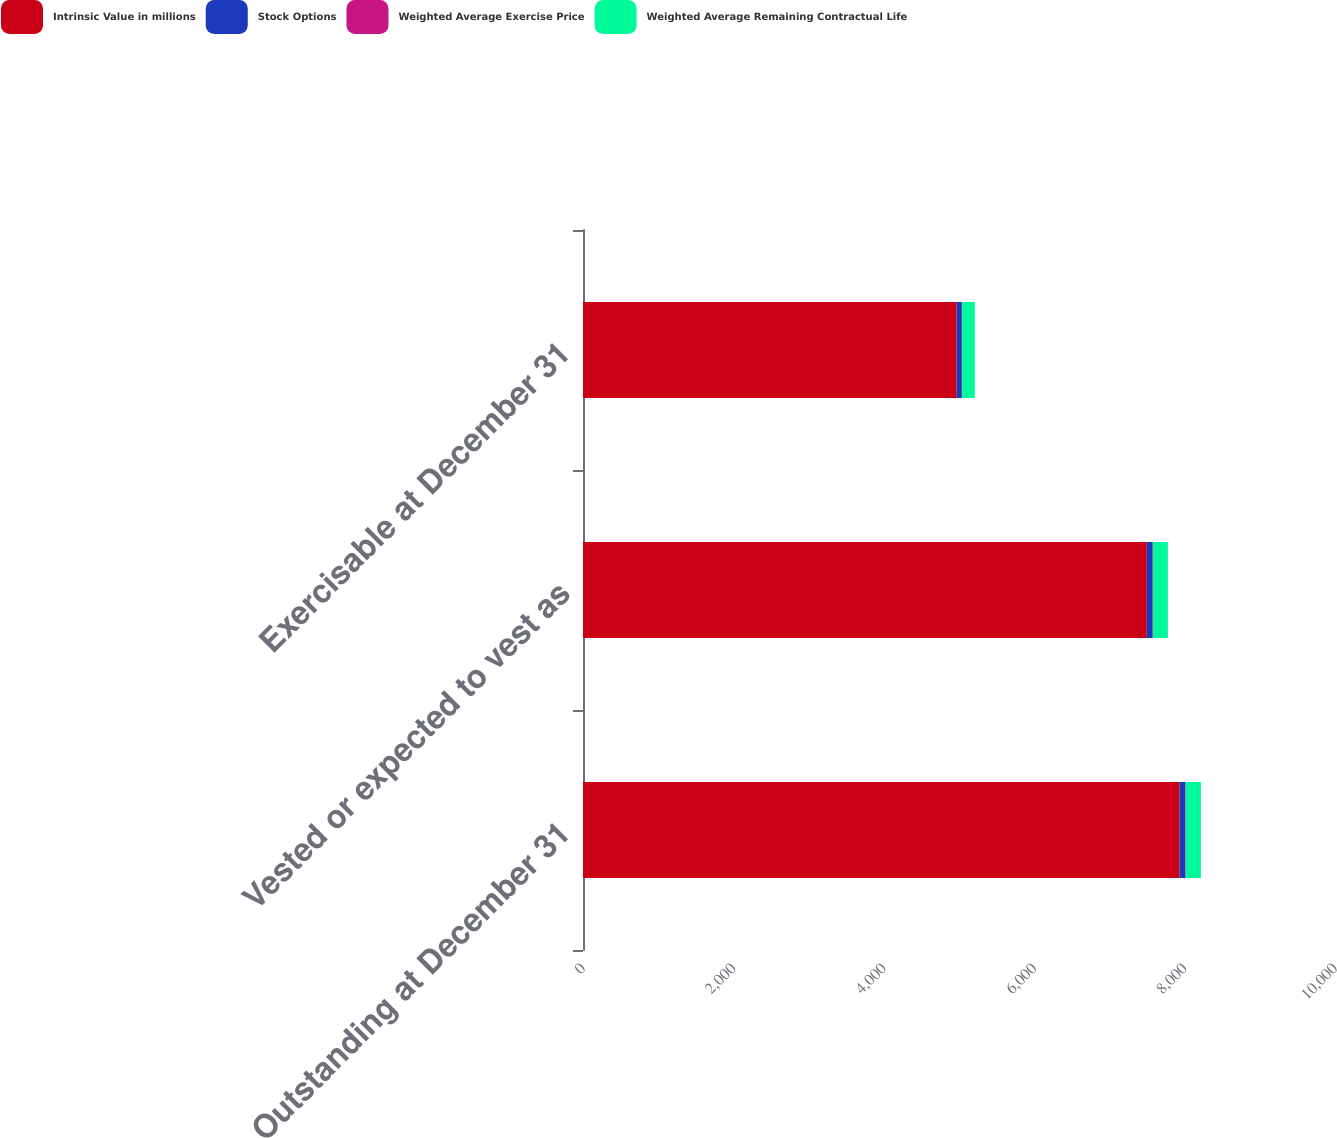Convert chart. <chart><loc_0><loc_0><loc_500><loc_500><stacked_bar_chart><ecel><fcel>Outstanding at December 31<fcel>Vested or expected to vest as<fcel>Exercisable at December 31<nl><fcel>Intrinsic Value in millions<fcel>7931<fcel>7497<fcel>4969<nl><fcel>Stock Options<fcel>78.73<fcel>77.59<fcel>68.67<nl><fcel>Weighted Average Exercise Price<fcel>5.7<fcel>5.5<fcel>3.9<nl><fcel>Weighted Average Remaining Contractual Life<fcel>201.1<fcel>197.4<fcel>168.6<nl></chart> 